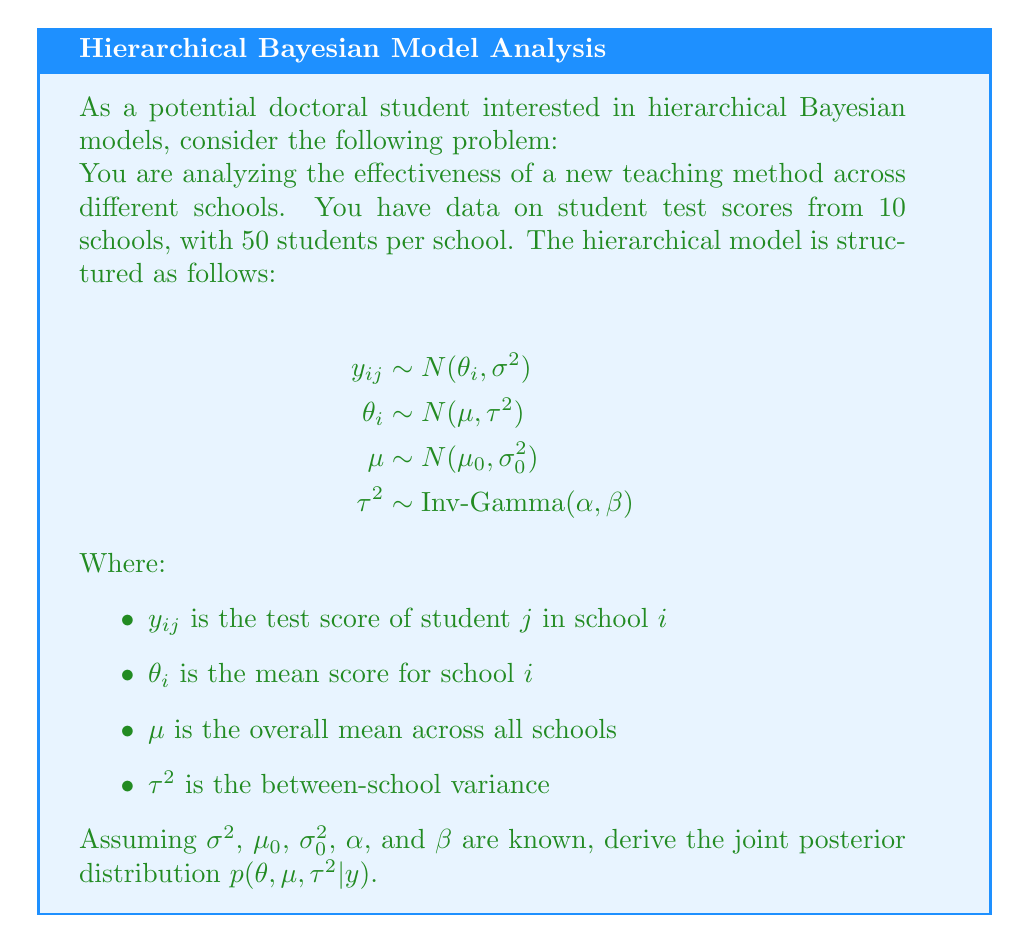Could you help me with this problem? To derive the joint posterior distribution, we'll use Bayes' theorem and the hierarchical structure of the model. Let's proceed step-by-step:

1) First, write out Bayes' theorem for the joint posterior:

   $$p(\theta, \mu, \tau^2 | y) \propto p(y | \theta, \mu, \tau^2) \cdot p(\theta | \mu, \tau^2) \cdot p(\mu) \cdot p(\tau^2)$$

2) Now, let's break down each component:

   a) Likelihood: $p(y | \theta, \mu, \tau^2) = \prod_{i=1}^{10} \prod_{j=1}^{50} N(y_{ij} | \theta_i, \sigma^2)$
   
   b) Prior for $\theta_i$: $p(\theta | \mu, \tau^2) = \prod_{i=1}^{10} N(\theta_i | \mu, \tau^2)$
   
   c) Prior for $\mu$: $p(\mu) = N(\mu | \mu_0, \sigma_0^2)$
   
   d) Prior for $\tau^2$: $p(\tau^2) = \text{Inv-Gamma}(\tau^2 | \alpha, \beta)$

3) Substitute these into Bayes' theorem:

   $$p(\theta, \mu, \tau^2 | y) \propto \prod_{i=1}^{10} \prod_{j=1}^{50} N(y_{ij} | \theta_i, \sigma^2) \cdot \prod_{i=1}^{10} N(\theta_i | \mu, \tau^2) \cdot N(\mu | \mu_0, \sigma_0^2) \cdot \text{Inv-Gamma}(\tau^2 | \alpha, \beta)$$

4) Expand the normal distributions:

   $$\begin{align}
   p(\theta, \mu, \tau^2 | y) \propto & \prod_{i=1}^{10} \prod_{j=1}^{50} \exp\left(-\frac{(y_{ij} - \theta_i)^2}{2\sigma^2}\right) \cdot \\
   & \prod_{i=1}^{10} \exp\left(-\frac{(\theta_i - \mu)^2}{2\tau^2}\right) \cdot \\
   & \exp\left(-\frac{(\mu - \mu_0)^2}{2\sigma_0^2}\right) \cdot \\
   & (\tau^2)^{-(\alpha+1)} \exp\left(-\frac{\beta}{\tau^2}\right)
   \end{align}$$

5) Combine the exponents:

   $$\begin{align}
   p(\theta, \mu, \tau^2 | y) \propto & \exp\left(-\frac{1}{2\sigma^2}\sum_{i=1}^{10}\sum_{j=1}^{50}(y_{ij} - \theta_i)^2\right) \cdot \\
   & \exp\left(-\frac{1}{2\tau^2}\sum_{i=1}^{10}(\theta_i - \mu)^2\right) \cdot \\
   & \exp\left(-\frac{(\mu - \mu_0)^2}{2\sigma_0^2}\right) \cdot \\
   & (\tau^2)^{-(\alpha+1)} \exp\left(-\frac{\beta}{\tau^2}\right)
   \end{align}$$

This is the unnormalized joint posterior distribution for $\theta$, $\mu$, and $\tau^2$ given the data $y$.
Answer: $$p(\theta, \mu, \tau^2 | y) \propto \exp\left(-\frac{1}{2\sigma^2}\sum_{i,j}(y_{ij} - \theta_i)^2 - \frac{1}{2\tau^2}\sum_{i}(\theta_i - \mu)^2 - \frac{(\mu - \mu_0)^2}{2\sigma_0^2} - \frac{\beta}{\tau^2}\right) \cdot (\tau^2)^{-(\alpha+1)}$$ 